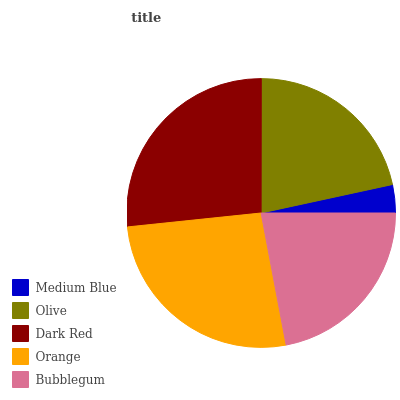Is Medium Blue the minimum?
Answer yes or no. Yes. Is Dark Red the maximum?
Answer yes or no. Yes. Is Olive the minimum?
Answer yes or no. No. Is Olive the maximum?
Answer yes or no. No. Is Olive greater than Medium Blue?
Answer yes or no. Yes. Is Medium Blue less than Olive?
Answer yes or no. Yes. Is Medium Blue greater than Olive?
Answer yes or no. No. Is Olive less than Medium Blue?
Answer yes or no. No. Is Bubblegum the high median?
Answer yes or no. Yes. Is Bubblegum the low median?
Answer yes or no. Yes. Is Medium Blue the high median?
Answer yes or no. No. Is Orange the low median?
Answer yes or no. No. 